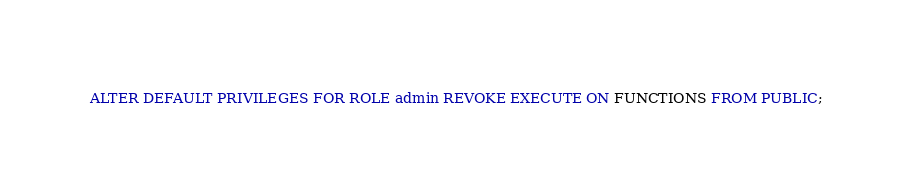Convert code to text. <code><loc_0><loc_0><loc_500><loc_500><_SQL_>ALTER DEFAULT PRIVILEGES FOR ROLE admin REVOKE EXECUTE ON FUNCTIONS FROM PUBLIC;
</code> 